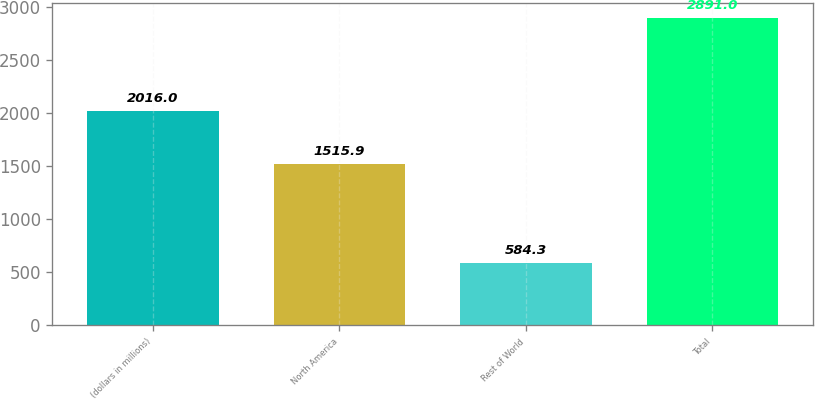Convert chart to OTSL. <chart><loc_0><loc_0><loc_500><loc_500><bar_chart><fcel>(dollars in millions)<fcel>North America<fcel>Rest of World<fcel>Total<nl><fcel>2016<fcel>1515.9<fcel>584.3<fcel>2891<nl></chart> 